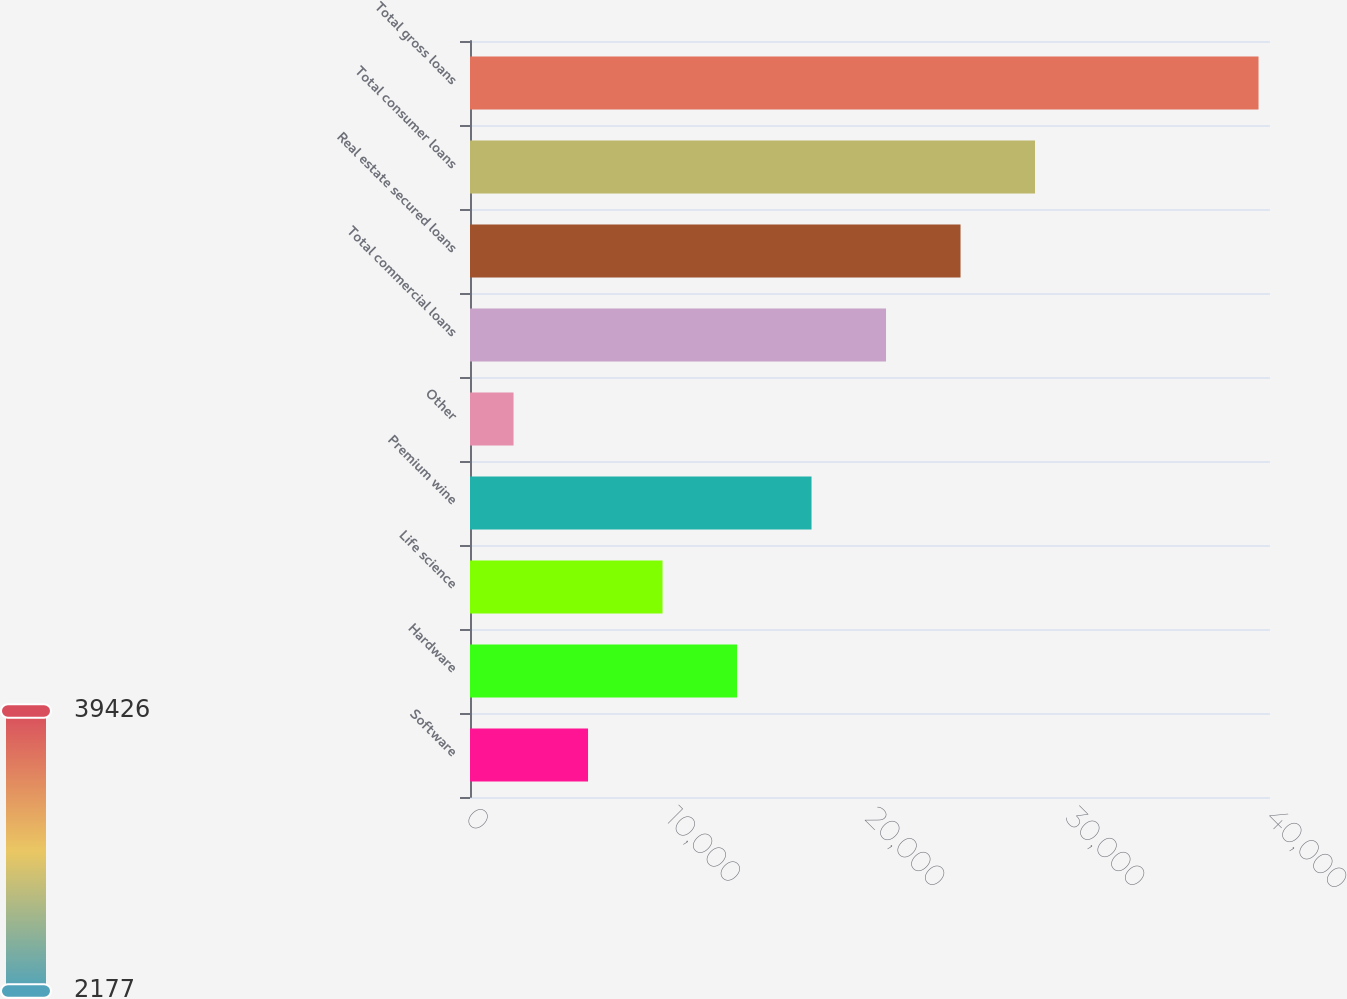Convert chart to OTSL. <chart><loc_0><loc_0><loc_500><loc_500><bar_chart><fcel>Software<fcel>Hardware<fcel>Life science<fcel>Premium wine<fcel>Other<fcel>Total commercial loans<fcel>Real estate secured loans<fcel>Total consumer loans<fcel>Total gross loans<nl><fcel>5901.9<fcel>13351.7<fcel>9626.8<fcel>17076.6<fcel>2177<fcel>20801.5<fcel>24526.4<fcel>28251.3<fcel>39426<nl></chart> 